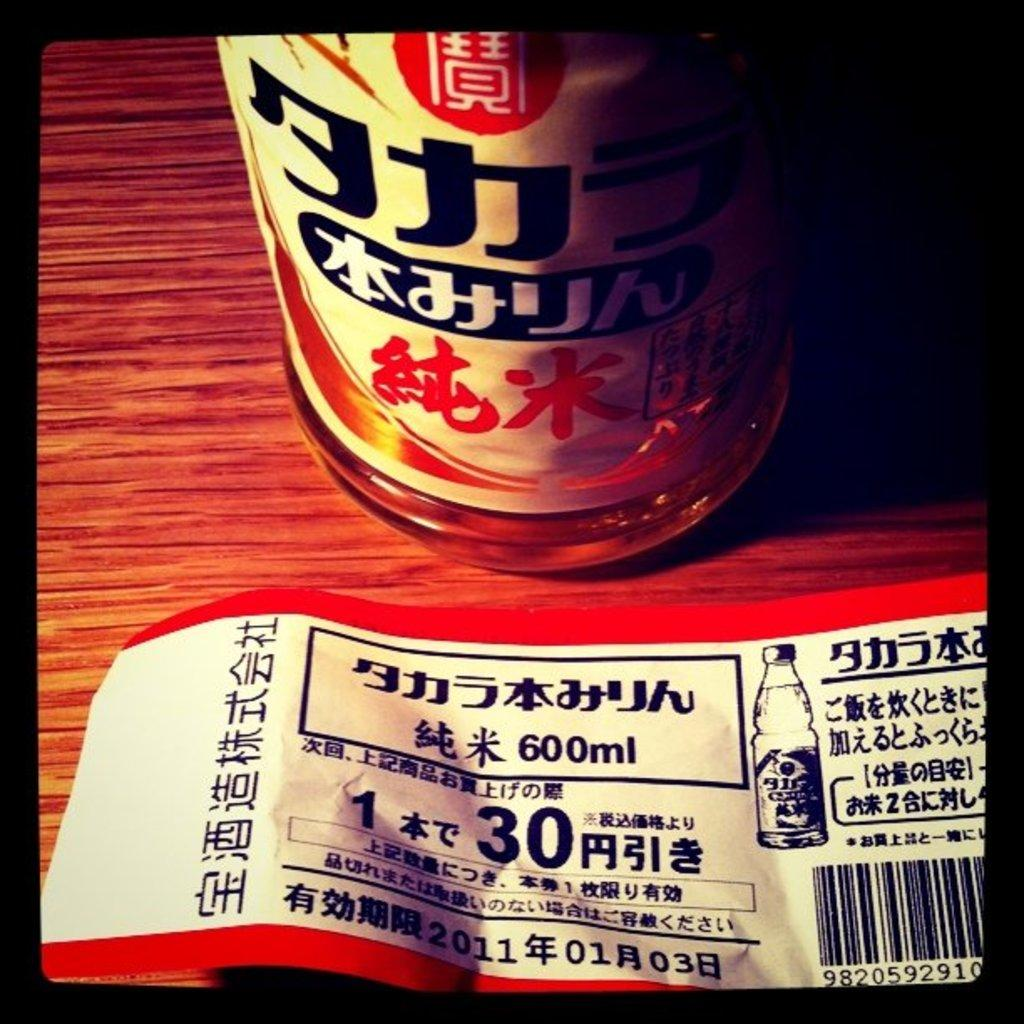What piece of furniture is present in the image? There is a table in the image. What objects are on the table? There is a bottle and a poster on the table. What is the condition of the bottle? The bottle has a sticker on it. What type of learning is taking place at the cemetery in the image? There is no cemetery present in the image, and therefore no learning is taking place in a cemetery. 